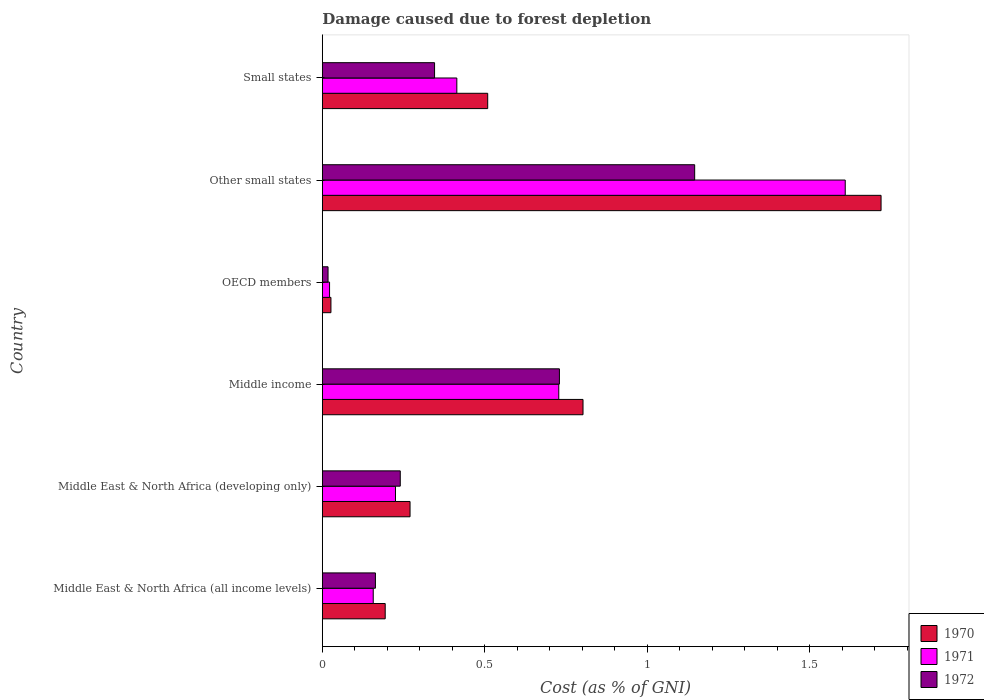Are the number of bars on each tick of the Y-axis equal?
Your answer should be very brief. Yes. How many bars are there on the 5th tick from the top?
Make the answer very short. 3. How many bars are there on the 6th tick from the bottom?
Your answer should be very brief. 3. What is the label of the 4th group of bars from the top?
Provide a succinct answer. Middle income. In how many cases, is the number of bars for a given country not equal to the number of legend labels?
Your response must be concise. 0. What is the cost of damage caused due to forest depletion in 1970 in OECD members?
Offer a terse response. 0.03. Across all countries, what is the maximum cost of damage caused due to forest depletion in 1970?
Offer a terse response. 1.72. Across all countries, what is the minimum cost of damage caused due to forest depletion in 1971?
Your response must be concise. 0.02. In which country was the cost of damage caused due to forest depletion in 1971 maximum?
Give a very brief answer. Other small states. In which country was the cost of damage caused due to forest depletion in 1971 minimum?
Provide a succinct answer. OECD members. What is the total cost of damage caused due to forest depletion in 1971 in the graph?
Your response must be concise. 3.15. What is the difference between the cost of damage caused due to forest depletion in 1970 in Middle East & North Africa (developing only) and that in OECD members?
Your answer should be very brief. 0.24. What is the difference between the cost of damage caused due to forest depletion in 1971 in Other small states and the cost of damage caused due to forest depletion in 1972 in Middle East & North Africa (developing only)?
Your response must be concise. 1.37. What is the average cost of damage caused due to forest depletion in 1972 per country?
Keep it short and to the point. 0.44. What is the difference between the cost of damage caused due to forest depletion in 1972 and cost of damage caused due to forest depletion in 1971 in Other small states?
Your answer should be very brief. -0.46. What is the ratio of the cost of damage caused due to forest depletion in 1972 in Middle East & North Africa (all income levels) to that in Other small states?
Offer a very short reply. 0.14. Is the cost of damage caused due to forest depletion in 1971 in Middle East & North Africa (developing only) less than that in OECD members?
Give a very brief answer. No. What is the difference between the highest and the second highest cost of damage caused due to forest depletion in 1972?
Offer a very short reply. 0.42. What is the difference between the highest and the lowest cost of damage caused due to forest depletion in 1970?
Keep it short and to the point. 1.69. Is the sum of the cost of damage caused due to forest depletion in 1972 in OECD members and Other small states greater than the maximum cost of damage caused due to forest depletion in 1971 across all countries?
Offer a very short reply. No. What does the 3rd bar from the top in Small states represents?
Make the answer very short. 1970. What does the 1st bar from the bottom in Middle East & North Africa (all income levels) represents?
Provide a short and direct response. 1970. How many bars are there?
Make the answer very short. 18. Are all the bars in the graph horizontal?
Offer a very short reply. Yes. What is the difference between two consecutive major ticks on the X-axis?
Provide a short and direct response. 0.5. Does the graph contain grids?
Give a very brief answer. No. How many legend labels are there?
Make the answer very short. 3. What is the title of the graph?
Provide a succinct answer. Damage caused due to forest depletion. Does "2005" appear as one of the legend labels in the graph?
Your answer should be compact. No. What is the label or title of the X-axis?
Offer a very short reply. Cost (as % of GNI). What is the Cost (as % of GNI) in 1970 in Middle East & North Africa (all income levels)?
Keep it short and to the point. 0.19. What is the Cost (as % of GNI) in 1971 in Middle East & North Africa (all income levels)?
Provide a succinct answer. 0.16. What is the Cost (as % of GNI) in 1972 in Middle East & North Africa (all income levels)?
Ensure brevity in your answer.  0.16. What is the Cost (as % of GNI) of 1970 in Middle East & North Africa (developing only)?
Your response must be concise. 0.27. What is the Cost (as % of GNI) of 1971 in Middle East & North Africa (developing only)?
Make the answer very short. 0.23. What is the Cost (as % of GNI) of 1972 in Middle East & North Africa (developing only)?
Your answer should be very brief. 0.24. What is the Cost (as % of GNI) in 1970 in Middle income?
Provide a short and direct response. 0.8. What is the Cost (as % of GNI) of 1971 in Middle income?
Offer a very short reply. 0.73. What is the Cost (as % of GNI) in 1972 in Middle income?
Your response must be concise. 0.73. What is the Cost (as % of GNI) in 1970 in OECD members?
Make the answer very short. 0.03. What is the Cost (as % of GNI) in 1971 in OECD members?
Your answer should be compact. 0.02. What is the Cost (as % of GNI) of 1972 in OECD members?
Your answer should be compact. 0.02. What is the Cost (as % of GNI) in 1970 in Other small states?
Your answer should be compact. 1.72. What is the Cost (as % of GNI) in 1971 in Other small states?
Make the answer very short. 1.61. What is the Cost (as % of GNI) of 1972 in Other small states?
Make the answer very short. 1.15. What is the Cost (as % of GNI) of 1970 in Small states?
Make the answer very short. 0.51. What is the Cost (as % of GNI) in 1971 in Small states?
Provide a short and direct response. 0.41. What is the Cost (as % of GNI) in 1972 in Small states?
Your response must be concise. 0.35. Across all countries, what is the maximum Cost (as % of GNI) of 1970?
Make the answer very short. 1.72. Across all countries, what is the maximum Cost (as % of GNI) in 1971?
Your answer should be compact. 1.61. Across all countries, what is the maximum Cost (as % of GNI) in 1972?
Your answer should be very brief. 1.15. Across all countries, what is the minimum Cost (as % of GNI) of 1970?
Ensure brevity in your answer.  0.03. Across all countries, what is the minimum Cost (as % of GNI) in 1971?
Your answer should be compact. 0.02. Across all countries, what is the minimum Cost (as % of GNI) in 1972?
Give a very brief answer. 0.02. What is the total Cost (as % of GNI) of 1970 in the graph?
Make the answer very short. 3.52. What is the total Cost (as % of GNI) in 1971 in the graph?
Keep it short and to the point. 3.15. What is the total Cost (as % of GNI) of 1972 in the graph?
Keep it short and to the point. 2.64. What is the difference between the Cost (as % of GNI) in 1970 in Middle East & North Africa (all income levels) and that in Middle East & North Africa (developing only)?
Your answer should be very brief. -0.08. What is the difference between the Cost (as % of GNI) in 1971 in Middle East & North Africa (all income levels) and that in Middle East & North Africa (developing only)?
Provide a succinct answer. -0.07. What is the difference between the Cost (as % of GNI) in 1972 in Middle East & North Africa (all income levels) and that in Middle East & North Africa (developing only)?
Your response must be concise. -0.08. What is the difference between the Cost (as % of GNI) in 1970 in Middle East & North Africa (all income levels) and that in Middle income?
Your answer should be compact. -0.61. What is the difference between the Cost (as % of GNI) in 1971 in Middle East & North Africa (all income levels) and that in Middle income?
Your answer should be compact. -0.57. What is the difference between the Cost (as % of GNI) of 1972 in Middle East & North Africa (all income levels) and that in Middle income?
Your response must be concise. -0.57. What is the difference between the Cost (as % of GNI) in 1970 in Middle East & North Africa (all income levels) and that in OECD members?
Ensure brevity in your answer.  0.17. What is the difference between the Cost (as % of GNI) in 1971 in Middle East & North Africa (all income levels) and that in OECD members?
Give a very brief answer. 0.13. What is the difference between the Cost (as % of GNI) in 1972 in Middle East & North Africa (all income levels) and that in OECD members?
Offer a terse response. 0.15. What is the difference between the Cost (as % of GNI) in 1970 in Middle East & North Africa (all income levels) and that in Other small states?
Give a very brief answer. -1.53. What is the difference between the Cost (as % of GNI) of 1971 in Middle East & North Africa (all income levels) and that in Other small states?
Your response must be concise. -1.45. What is the difference between the Cost (as % of GNI) of 1972 in Middle East & North Africa (all income levels) and that in Other small states?
Your answer should be very brief. -0.98. What is the difference between the Cost (as % of GNI) in 1970 in Middle East & North Africa (all income levels) and that in Small states?
Ensure brevity in your answer.  -0.32. What is the difference between the Cost (as % of GNI) in 1971 in Middle East & North Africa (all income levels) and that in Small states?
Your response must be concise. -0.26. What is the difference between the Cost (as % of GNI) in 1972 in Middle East & North Africa (all income levels) and that in Small states?
Offer a very short reply. -0.18. What is the difference between the Cost (as % of GNI) in 1970 in Middle East & North Africa (developing only) and that in Middle income?
Your response must be concise. -0.53. What is the difference between the Cost (as % of GNI) in 1971 in Middle East & North Africa (developing only) and that in Middle income?
Ensure brevity in your answer.  -0.5. What is the difference between the Cost (as % of GNI) in 1972 in Middle East & North Africa (developing only) and that in Middle income?
Keep it short and to the point. -0.49. What is the difference between the Cost (as % of GNI) of 1970 in Middle East & North Africa (developing only) and that in OECD members?
Give a very brief answer. 0.24. What is the difference between the Cost (as % of GNI) of 1971 in Middle East & North Africa (developing only) and that in OECD members?
Your response must be concise. 0.2. What is the difference between the Cost (as % of GNI) in 1972 in Middle East & North Africa (developing only) and that in OECD members?
Ensure brevity in your answer.  0.22. What is the difference between the Cost (as % of GNI) of 1970 in Middle East & North Africa (developing only) and that in Other small states?
Give a very brief answer. -1.45. What is the difference between the Cost (as % of GNI) in 1971 in Middle East & North Africa (developing only) and that in Other small states?
Keep it short and to the point. -1.38. What is the difference between the Cost (as % of GNI) of 1972 in Middle East & North Africa (developing only) and that in Other small states?
Your response must be concise. -0.91. What is the difference between the Cost (as % of GNI) in 1970 in Middle East & North Africa (developing only) and that in Small states?
Make the answer very short. -0.24. What is the difference between the Cost (as % of GNI) in 1971 in Middle East & North Africa (developing only) and that in Small states?
Your response must be concise. -0.19. What is the difference between the Cost (as % of GNI) in 1972 in Middle East & North Africa (developing only) and that in Small states?
Make the answer very short. -0.11. What is the difference between the Cost (as % of GNI) of 1970 in Middle income and that in OECD members?
Your response must be concise. 0.78. What is the difference between the Cost (as % of GNI) of 1971 in Middle income and that in OECD members?
Provide a succinct answer. 0.71. What is the difference between the Cost (as % of GNI) of 1972 in Middle income and that in OECD members?
Provide a short and direct response. 0.71. What is the difference between the Cost (as % of GNI) in 1970 in Middle income and that in Other small states?
Make the answer very short. -0.92. What is the difference between the Cost (as % of GNI) in 1971 in Middle income and that in Other small states?
Your answer should be very brief. -0.88. What is the difference between the Cost (as % of GNI) in 1972 in Middle income and that in Other small states?
Provide a succinct answer. -0.42. What is the difference between the Cost (as % of GNI) of 1970 in Middle income and that in Small states?
Make the answer very short. 0.29. What is the difference between the Cost (as % of GNI) in 1971 in Middle income and that in Small states?
Make the answer very short. 0.31. What is the difference between the Cost (as % of GNI) in 1972 in Middle income and that in Small states?
Keep it short and to the point. 0.38. What is the difference between the Cost (as % of GNI) of 1970 in OECD members and that in Other small states?
Your response must be concise. -1.69. What is the difference between the Cost (as % of GNI) in 1971 in OECD members and that in Other small states?
Ensure brevity in your answer.  -1.59. What is the difference between the Cost (as % of GNI) of 1972 in OECD members and that in Other small states?
Give a very brief answer. -1.13. What is the difference between the Cost (as % of GNI) in 1970 in OECD members and that in Small states?
Your answer should be compact. -0.48. What is the difference between the Cost (as % of GNI) in 1971 in OECD members and that in Small states?
Ensure brevity in your answer.  -0.39. What is the difference between the Cost (as % of GNI) of 1972 in OECD members and that in Small states?
Provide a succinct answer. -0.33. What is the difference between the Cost (as % of GNI) in 1970 in Other small states and that in Small states?
Your answer should be compact. 1.21. What is the difference between the Cost (as % of GNI) in 1971 in Other small states and that in Small states?
Make the answer very short. 1.2. What is the difference between the Cost (as % of GNI) of 1972 in Other small states and that in Small states?
Provide a short and direct response. 0.8. What is the difference between the Cost (as % of GNI) of 1970 in Middle East & North Africa (all income levels) and the Cost (as % of GNI) of 1971 in Middle East & North Africa (developing only)?
Keep it short and to the point. -0.03. What is the difference between the Cost (as % of GNI) of 1970 in Middle East & North Africa (all income levels) and the Cost (as % of GNI) of 1972 in Middle East & North Africa (developing only)?
Your answer should be very brief. -0.05. What is the difference between the Cost (as % of GNI) of 1971 in Middle East & North Africa (all income levels) and the Cost (as % of GNI) of 1972 in Middle East & North Africa (developing only)?
Provide a succinct answer. -0.08. What is the difference between the Cost (as % of GNI) of 1970 in Middle East & North Africa (all income levels) and the Cost (as % of GNI) of 1971 in Middle income?
Ensure brevity in your answer.  -0.53. What is the difference between the Cost (as % of GNI) of 1970 in Middle East & North Africa (all income levels) and the Cost (as % of GNI) of 1972 in Middle income?
Offer a terse response. -0.54. What is the difference between the Cost (as % of GNI) of 1971 in Middle East & North Africa (all income levels) and the Cost (as % of GNI) of 1972 in Middle income?
Make the answer very short. -0.57. What is the difference between the Cost (as % of GNI) of 1970 in Middle East & North Africa (all income levels) and the Cost (as % of GNI) of 1971 in OECD members?
Offer a terse response. 0.17. What is the difference between the Cost (as % of GNI) in 1970 in Middle East & North Africa (all income levels) and the Cost (as % of GNI) in 1972 in OECD members?
Offer a terse response. 0.18. What is the difference between the Cost (as % of GNI) in 1971 in Middle East & North Africa (all income levels) and the Cost (as % of GNI) in 1972 in OECD members?
Offer a very short reply. 0.14. What is the difference between the Cost (as % of GNI) in 1970 in Middle East & North Africa (all income levels) and the Cost (as % of GNI) in 1971 in Other small states?
Provide a short and direct response. -1.42. What is the difference between the Cost (as % of GNI) of 1970 in Middle East & North Africa (all income levels) and the Cost (as % of GNI) of 1972 in Other small states?
Provide a short and direct response. -0.95. What is the difference between the Cost (as % of GNI) in 1971 in Middle East & North Africa (all income levels) and the Cost (as % of GNI) in 1972 in Other small states?
Give a very brief answer. -0.99. What is the difference between the Cost (as % of GNI) in 1970 in Middle East & North Africa (all income levels) and the Cost (as % of GNI) in 1971 in Small states?
Your answer should be very brief. -0.22. What is the difference between the Cost (as % of GNI) of 1970 in Middle East & North Africa (all income levels) and the Cost (as % of GNI) of 1972 in Small states?
Offer a terse response. -0.15. What is the difference between the Cost (as % of GNI) in 1971 in Middle East & North Africa (all income levels) and the Cost (as % of GNI) in 1972 in Small states?
Your answer should be compact. -0.19. What is the difference between the Cost (as % of GNI) in 1970 in Middle East & North Africa (developing only) and the Cost (as % of GNI) in 1971 in Middle income?
Your response must be concise. -0.46. What is the difference between the Cost (as % of GNI) in 1970 in Middle East & North Africa (developing only) and the Cost (as % of GNI) in 1972 in Middle income?
Your answer should be compact. -0.46. What is the difference between the Cost (as % of GNI) of 1971 in Middle East & North Africa (developing only) and the Cost (as % of GNI) of 1972 in Middle income?
Keep it short and to the point. -0.5. What is the difference between the Cost (as % of GNI) of 1970 in Middle East & North Africa (developing only) and the Cost (as % of GNI) of 1971 in OECD members?
Offer a very short reply. 0.25. What is the difference between the Cost (as % of GNI) of 1970 in Middle East & North Africa (developing only) and the Cost (as % of GNI) of 1972 in OECD members?
Your answer should be very brief. 0.25. What is the difference between the Cost (as % of GNI) of 1971 in Middle East & North Africa (developing only) and the Cost (as % of GNI) of 1972 in OECD members?
Provide a succinct answer. 0.21. What is the difference between the Cost (as % of GNI) of 1970 in Middle East & North Africa (developing only) and the Cost (as % of GNI) of 1971 in Other small states?
Ensure brevity in your answer.  -1.34. What is the difference between the Cost (as % of GNI) in 1970 in Middle East & North Africa (developing only) and the Cost (as % of GNI) in 1972 in Other small states?
Ensure brevity in your answer.  -0.88. What is the difference between the Cost (as % of GNI) of 1971 in Middle East & North Africa (developing only) and the Cost (as % of GNI) of 1972 in Other small states?
Provide a succinct answer. -0.92. What is the difference between the Cost (as % of GNI) of 1970 in Middle East & North Africa (developing only) and the Cost (as % of GNI) of 1971 in Small states?
Provide a short and direct response. -0.14. What is the difference between the Cost (as % of GNI) of 1970 in Middle East & North Africa (developing only) and the Cost (as % of GNI) of 1972 in Small states?
Provide a succinct answer. -0.08. What is the difference between the Cost (as % of GNI) of 1971 in Middle East & North Africa (developing only) and the Cost (as % of GNI) of 1972 in Small states?
Provide a short and direct response. -0.12. What is the difference between the Cost (as % of GNI) of 1970 in Middle income and the Cost (as % of GNI) of 1971 in OECD members?
Provide a succinct answer. 0.78. What is the difference between the Cost (as % of GNI) of 1970 in Middle income and the Cost (as % of GNI) of 1972 in OECD members?
Give a very brief answer. 0.78. What is the difference between the Cost (as % of GNI) in 1971 in Middle income and the Cost (as % of GNI) in 1972 in OECD members?
Offer a terse response. 0.71. What is the difference between the Cost (as % of GNI) in 1970 in Middle income and the Cost (as % of GNI) in 1971 in Other small states?
Keep it short and to the point. -0.81. What is the difference between the Cost (as % of GNI) in 1970 in Middle income and the Cost (as % of GNI) in 1972 in Other small states?
Offer a terse response. -0.34. What is the difference between the Cost (as % of GNI) of 1971 in Middle income and the Cost (as % of GNI) of 1972 in Other small states?
Offer a very short reply. -0.42. What is the difference between the Cost (as % of GNI) in 1970 in Middle income and the Cost (as % of GNI) in 1971 in Small states?
Offer a terse response. 0.39. What is the difference between the Cost (as % of GNI) of 1970 in Middle income and the Cost (as % of GNI) of 1972 in Small states?
Ensure brevity in your answer.  0.46. What is the difference between the Cost (as % of GNI) of 1971 in Middle income and the Cost (as % of GNI) of 1972 in Small states?
Provide a short and direct response. 0.38. What is the difference between the Cost (as % of GNI) of 1970 in OECD members and the Cost (as % of GNI) of 1971 in Other small states?
Your answer should be compact. -1.58. What is the difference between the Cost (as % of GNI) in 1970 in OECD members and the Cost (as % of GNI) in 1972 in Other small states?
Offer a terse response. -1.12. What is the difference between the Cost (as % of GNI) in 1971 in OECD members and the Cost (as % of GNI) in 1972 in Other small states?
Offer a very short reply. -1.12. What is the difference between the Cost (as % of GNI) of 1970 in OECD members and the Cost (as % of GNI) of 1971 in Small states?
Ensure brevity in your answer.  -0.39. What is the difference between the Cost (as % of GNI) in 1970 in OECD members and the Cost (as % of GNI) in 1972 in Small states?
Give a very brief answer. -0.32. What is the difference between the Cost (as % of GNI) of 1971 in OECD members and the Cost (as % of GNI) of 1972 in Small states?
Your response must be concise. -0.32. What is the difference between the Cost (as % of GNI) of 1970 in Other small states and the Cost (as % of GNI) of 1971 in Small states?
Ensure brevity in your answer.  1.31. What is the difference between the Cost (as % of GNI) in 1970 in Other small states and the Cost (as % of GNI) in 1972 in Small states?
Your response must be concise. 1.37. What is the difference between the Cost (as % of GNI) of 1971 in Other small states and the Cost (as % of GNI) of 1972 in Small states?
Give a very brief answer. 1.26. What is the average Cost (as % of GNI) of 1970 per country?
Your answer should be compact. 0.59. What is the average Cost (as % of GNI) in 1971 per country?
Offer a very short reply. 0.53. What is the average Cost (as % of GNI) in 1972 per country?
Make the answer very short. 0.44. What is the difference between the Cost (as % of GNI) in 1970 and Cost (as % of GNI) in 1971 in Middle East & North Africa (all income levels)?
Ensure brevity in your answer.  0.04. What is the difference between the Cost (as % of GNI) of 1970 and Cost (as % of GNI) of 1972 in Middle East & North Africa (all income levels)?
Make the answer very short. 0.03. What is the difference between the Cost (as % of GNI) in 1971 and Cost (as % of GNI) in 1972 in Middle East & North Africa (all income levels)?
Keep it short and to the point. -0.01. What is the difference between the Cost (as % of GNI) in 1970 and Cost (as % of GNI) in 1971 in Middle East & North Africa (developing only)?
Give a very brief answer. 0.04. What is the difference between the Cost (as % of GNI) of 1970 and Cost (as % of GNI) of 1972 in Middle East & North Africa (developing only)?
Ensure brevity in your answer.  0.03. What is the difference between the Cost (as % of GNI) of 1971 and Cost (as % of GNI) of 1972 in Middle East & North Africa (developing only)?
Provide a succinct answer. -0.01. What is the difference between the Cost (as % of GNI) of 1970 and Cost (as % of GNI) of 1971 in Middle income?
Offer a very short reply. 0.07. What is the difference between the Cost (as % of GNI) of 1970 and Cost (as % of GNI) of 1972 in Middle income?
Ensure brevity in your answer.  0.07. What is the difference between the Cost (as % of GNI) in 1971 and Cost (as % of GNI) in 1972 in Middle income?
Your response must be concise. -0. What is the difference between the Cost (as % of GNI) of 1970 and Cost (as % of GNI) of 1971 in OECD members?
Offer a very short reply. 0. What is the difference between the Cost (as % of GNI) in 1970 and Cost (as % of GNI) in 1972 in OECD members?
Your response must be concise. 0.01. What is the difference between the Cost (as % of GNI) in 1971 and Cost (as % of GNI) in 1972 in OECD members?
Your response must be concise. 0. What is the difference between the Cost (as % of GNI) of 1970 and Cost (as % of GNI) of 1971 in Other small states?
Offer a very short reply. 0.11. What is the difference between the Cost (as % of GNI) of 1970 and Cost (as % of GNI) of 1972 in Other small states?
Keep it short and to the point. 0.57. What is the difference between the Cost (as % of GNI) in 1971 and Cost (as % of GNI) in 1972 in Other small states?
Your answer should be compact. 0.46. What is the difference between the Cost (as % of GNI) of 1970 and Cost (as % of GNI) of 1971 in Small states?
Offer a terse response. 0.1. What is the difference between the Cost (as % of GNI) of 1970 and Cost (as % of GNI) of 1972 in Small states?
Your response must be concise. 0.16. What is the difference between the Cost (as % of GNI) of 1971 and Cost (as % of GNI) of 1972 in Small states?
Your answer should be compact. 0.07. What is the ratio of the Cost (as % of GNI) in 1970 in Middle East & North Africa (all income levels) to that in Middle East & North Africa (developing only)?
Make the answer very short. 0.72. What is the ratio of the Cost (as % of GNI) in 1971 in Middle East & North Africa (all income levels) to that in Middle East & North Africa (developing only)?
Provide a short and direct response. 0.7. What is the ratio of the Cost (as % of GNI) of 1972 in Middle East & North Africa (all income levels) to that in Middle East & North Africa (developing only)?
Your answer should be compact. 0.68. What is the ratio of the Cost (as % of GNI) of 1970 in Middle East & North Africa (all income levels) to that in Middle income?
Give a very brief answer. 0.24. What is the ratio of the Cost (as % of GNI) of 1971 in Middle East & North Africa (all income levels) to that in Middle income?
Make the answer very short. 0.22. What is the ratio of the Cost (as % of GNI) of 1972 in Middle East & North Africa (all income levels) to that in Middle income?
Keep it short and to the point. 0.22. What is the ratio of the Cost (as % of GNI) in 1970 in Middle East & North Africa (all income levels) to that in OECD members?
Your answer should be very brief. 7.3. What is the ratio of the Cost (as % of GNI) of 1971 in Middle East & North Africa (all income levels) to that in OECD members?
Your response must be concise. 7.04. What is the ratio of the Cost (as % of GNI) in 1972 in Middle East & North Africa (all income levels) to that in OECD members?
Offer a very short reply. 9.29. What is the ratio of the Cost (as % of GNI) of 1970 in Middle East & North Africa (all income levels) to that in Other small states?
Provide a short and direct response. 0.11. What is the ratio of the Cost (as % of GNI) of 1971 in Middle East & North Africa (all income levels) to that in Other small states?
Make the answer very short. 0.1. What is the ratio of the Cost (as % of GNI) of 1972 in Middle East & North Africa (all income levels) to that in Other small states?
Give a very brief answer. 0.14. What is the ratio of the Cost (as % of GNI) of 1970 in Middle East & North Africa (all income levels) to that in Small states?
Keep it short and to the point. 0.38. What is the ratio of the Cost (as % of GNI) of 1971 in Middle East & North Africa (all income levels) to that in Small states?
Your answer should be compact. 0.38. What is the ratio of the Cost (as % of GNI) in 1972 in Middle East & North Africa (all income levels) to that in Small states?
Make the answer very short. 0.47. What is the ratio of the Cost (as % of GNI) of 1970 in Middle East & North Africa (developing only) to that in Middle income?
Your response must be concise. 0.34. What is the ratio of the Cost (as % of GNI) of 1971 in Middle East & North Africa (developing only) to that in Middle income?
Your answer should be very brief. 0.31. What is the ratio of the Cost (as % of GNI) in 1972 in Middle East & North Africa (developing only) to that in Middle income?
Offer a very short reply. 0.33. What is the ratio of the Cost (as % of GNI) of 1970 in Middle East & North Africa (developing only) to that in OECD members?
Make the answer very short. 10.19. What is the ratio of the Cost (as % of GNI) of 1971 in Middle East & North Africa (developing only) to that in OECD members?
Provide a succinct answer. 10.12. What is the ratio of the Cost (as % of GNI) of 1972 in Middle East & North Africa (developing only) to that in OECD members?
Give a very brief answer. 13.63. What is the ratio of the Cost (as % of GNI) of 1970 in Middle East & North Africa (developing only) to that in Other small states?
Offer a very short reply. 0.16. What is the ratio of the Cost (as % of GNI) of 1971 in Middle East & North Africa (developing only) to that in Other small states?
Your answer should be compact. 0.14. What is the ratio of the Cost (as % of GNI) in 1972 in Middle East & North Africa (developing only) to that in Other small states?
Ensure brevity in your answer.  0.21. What is the ratio of the Cost (as % of GNI) in 1970 in Middle East & North Africa (developing only) to that in Small states?
Keep it short and to the point. 0.53. What is the ratio of the Cost (as % of GNI) of 1971 in Middle East & North Africa (developing only) to that in Small states?
Ensure brevity in your answer.  0.54. What is the ratio of the Cost (as % of GNI) in 1972 in Middle East & North Africa (developing only) to that in Small states?
Make the answer very short. 0.69. What is the ratio of the Cost (as % of GNI) of 1970 in Middle income to that in OECD members?
Offer a very short reply. 30.28. What is the ratio of the Cost (as % of GNI) in 1971 in Middle income to that in OECD members?
Make the answer very short. 32.71. What is the ratio of the Cost (as % of GNI) in 1972 in Middle income to that in OECD members?
Give a very brief answer. 41.48. What is the ratio of the Cost (as % of GNI) of 1970 in Middle income to that in Other small states?
Give a very brief answer. 0.47. What is the ratio of the Cost (as % of GNI) in 1971 in Middle income to that in Other small states?
Offer a very short reply. 0.45. What is the ratio of the Cost (as % of GNI) of 1972 in Middle income to that in Other small states?
Your response must be concise. 0.64. What is the ratio of the Cost (as % of GNI) of 1970 in Middle income to that in Small states?
Provide a succinct answer. 1.58. What is the ratio of the Cost (as % of GNI) in 1971 in Middle income to that in Small states?
Keep it short and to the point. 1.76. What is the ratio of the Cost (as % of GNI) of 1972 in Middle income to that in Small states?
Your answer should be compact. 2.11. What is the ratio of the Cost (as % of GNI) in 1970 in OECD members to that in Other small states?
Give a very brief answer. 0.02. What is the ratio of the Cost (as % of GNI) in 1971 in OECD members to that in Other small states?
Offer a terse response. 0.01. What is the ratio of the Cost (as % of GNI) of 1972 in OECD members to that in Other small states?
Provide a succinct answer. 0.02. What is the ratio of the Cost (as % of GNI) of 1970 in OECD members to that in Small states?
Your answer should be compact. 0.05. What is the ratio of the Cost (as % of GNI) of 1971 in OECD members to that in Small states?
Offer a very short reply. 0.05. What is the ratio of the Cost (as % of GNI) of 1972 in OECD members to that in Small states?
Ensure brevity in your answer.  0.05. What is the ratio of the Cost (as % of GNI) of 1970 in Other small states to that in Small states?
Provide a short and direct response. 3.38. What is the ratio of the Cost (as % of GNI) in 1971 in Other small states to that in Small states?
Your answer should be very brief. 3.89. What is the ratio of the Cost (as % of GNI) in 1972 in Other small states to that in Small states?
Your answer should be very brief. 3.32. What is the difference between the highest and the second highest Cost (as % of GNI) in 1970?
Give a very brief answer. 0.92. What is the difference between the highest and the second highest Cost (as % of GNI) in 1971?
Give a very brief answer. 0.88. What is the difference between the highest and the second highest Cost (as % of GNI) in 1972?
Keep it short and to the point. 0.42. What is the difference between the highest and the lowest Cost (as % of GNI) of 1970?
Make the answer very short. 1.69. What is the difference between the highest and the lowest Cost (as % of GNI) in 1971?
Ensure brevity in your answer.  1.59. What is the difference between the highest and the lowest Cost (as % of GNI) of 1972?
Keep it short and to the point. 1.13. 